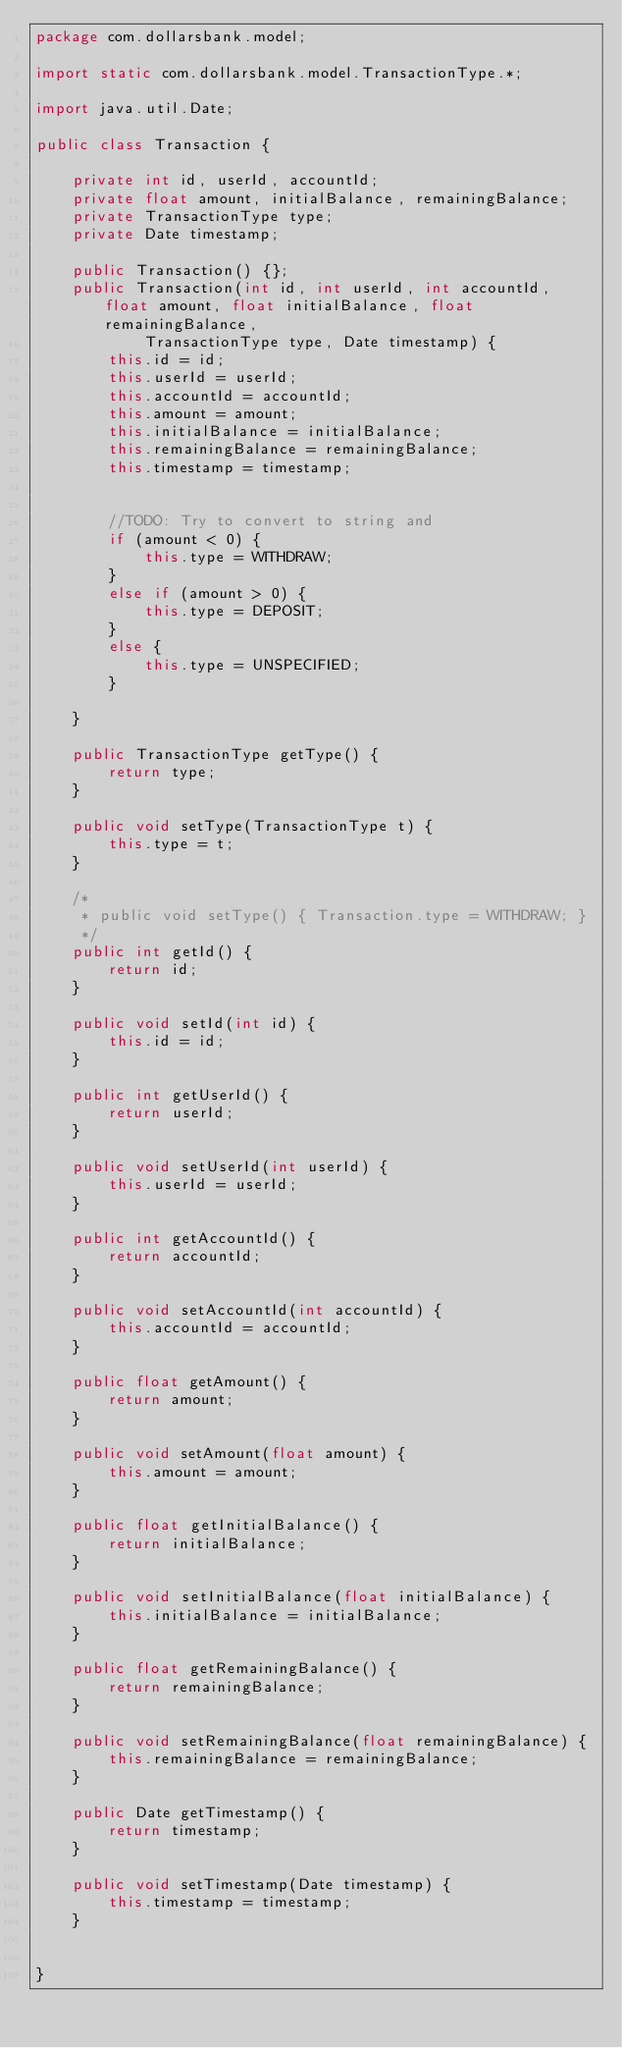<code> <loc_0><loc_0><loc_500><loc_500><_Java_>package com.dollarsbank.model;

import static com.dollarsbank.model.TransactionType.*;

import java.util.Date;

public class Transaction {

	private int id, userId, accountId;
	private float amount, initialBalance, remainingBalance;
	private TransactionType type;
	private Date timestamp;

	public Transaction() {};
	public Transaction(int id, int userId, int accountId, float amount, float initialBalance, float remainingBalance,
			TransactionType type, Date timestamp) {
		this.id = id;
		this.userId = userId;
		this.accountId = accountId;
		this.amount = amount;
		this.initialBalance = initialBalance;
		this.remainingBalance = remainingBalance;
		this.timestamp = timestamp;


		//TODO: Try to convert to string and
		if (amount < 0) {
			this.type = WITHDRAW;
		}
		else if (amount > 0) {
			this.type = DEPOSIT;
		}
		else {
			this.type = UNSPECIFIED;
		}

	}

	public TransactionType getType() {
		return type;
	}

	public void setType(TransactionType t) {
		this.type = t;
	}

	/*
	 * public void setType() { Transaction.type = WITHDRAW; }
	 */
	public int getId() {
		return id;
	}

	public void setId(int id) {
		this.id = id;
	}

	public int getUserId() {
		return userId;
	}

	public void setUserId(int userId) {
		this.userId = userId;
	}

	public int getAccountId() {
		return accountId;
	}

	public void setAccountId(int accountId) {
		this.accountId = accountId;
	}

	public float getAmount() {
		return amount;
	}

	public void setAmount(float amount) {
		this.amount = amount;
	}

	public float getInitialBalance() {
		return initialBalance;
	}

	public void setInitialBalance(float initialBalance) {
		this.initialBalance = initialBalance;
	}

	public float getRemainingBalance() {
		return remainingBalance;
	}

	public void setRemainingBalance(float remainingBalance) {
		this.remainingBalance = remainingBalance;
	}

	public Date getTimestamp() {
		return timestamp;
	}

	public void setTimestamp(Date timestamp) {
		this.timestamp = timestamp;
	}


}</code> 